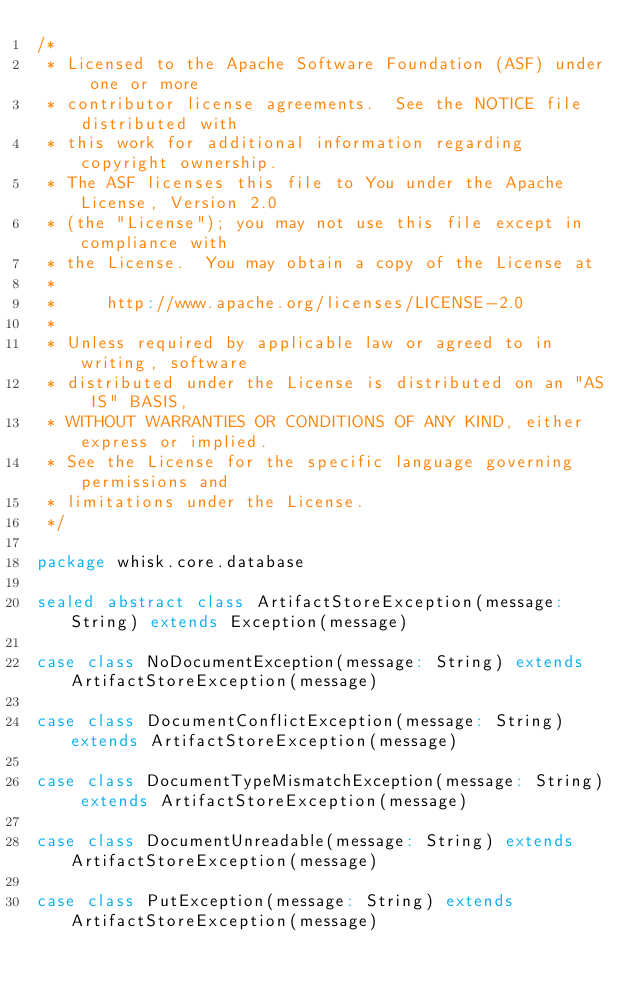Convert code to text. <code><loc_0><loc_0><loc_500><loc_500><_Scala_>/*
 * Licensed to the Apache Software Foundation (ASF) under one or more
 * contributor license agreements.  See the NOTICE file distributed with
 * this work for additional information regarding copyright ownership.
 * The ASF licenses this file to You under the Apache License, Version 2.0
 * (the "License"); you may not use this file except in compliance with
 * the License.  You may obtain a copy of the License at
 *
 *     http://www.apache.org/licenses/LICENSE-2.0
 *
 * Unless required by applicable law or agreed to in writing, software
 * distributed under the License is distributed on an "AS IS" BASIS,
 * WITHOUT WARRANTIES OR CONDITIONS OF ANY KIND, either express or implied.
 * See the License for the specific language governing permissions and
 * limitations under the License.
 */

package whisk.core.database

sealed abstract class ArtifactStoreException(message: String) extends Exception(message)

case class NoDocumentException(message: String) extends ArtifactStoreException(message)

case class DocumentConflictException(message: String) extends ArtifactStoreException(message)

case class DocumentTypeMismatchException(message: String) extends ArtifactStoreException(message)

case class DocumentUnreadable(message: String) extends ArtifactStoreException(message)

case class PutException(message: String) extends ArtifactStoreException(message)
</code> 